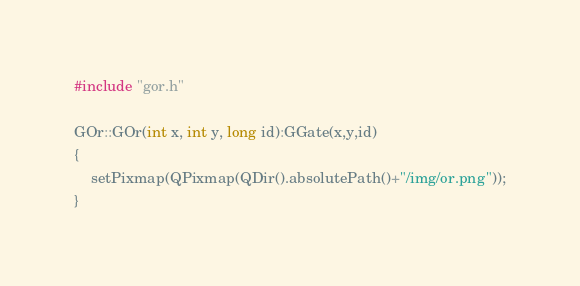<code> <loc_0><loc_0><loc_500><loc_500><_C++_>#include "gor.h"

GOr::GOr(int x, int y, long id):GGate(x,y,id)
{
    setPixmap(QPixmap(QDir().absolutePath()+"/img/or.png"));
}
</code> 